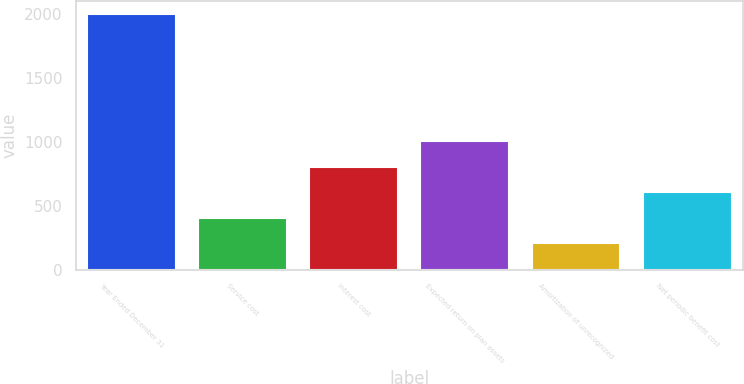Convert chart to OTSL. <chart><loc_0><loc_0><loc_500><loc_500><bar_chart><fcel>Year Ended December 31<fcel>Service cost<fcel>Interest cost<fcel>Expected return on plan assets<fcel>Amortization of unrecognized<fcel>Net periodic benefit cost<nl><fcel>2003<fcel>407.48<fcel>806.36<fcel>1005.8<fcel>208.04<fcel>606.92<nl></chart> 